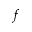Convert formula to latex. <formula><loc_0><loc_0><loc_500><loc_500>^ { f }</formula> 